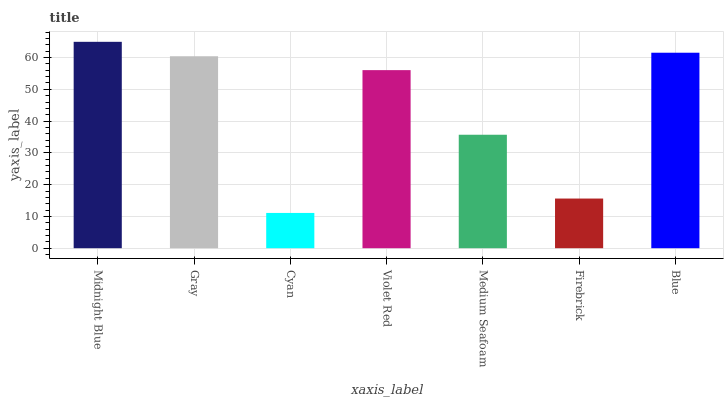Is Cyan the minimum?
Answer yes or no. Yes. Is Midnight Blue the maximum?
Answer yes or no. Yes. Is Gray the minimum?
Answer yes or no. No. Is Gray the maximum?
Answer yes or no. No. Is Midnight Blue greater than Gray?
Answer yes or no. Yes. Is Gray less than Midnight Blue?
Answer yes or no. Yes. Is Gray greater than Midnight Blue?
Answer yes or no. No. Is Midnight Blue less than Gray?
Answer yes or no. No. Is Violet Red the high median?
Answer yes or no. Yes. Is Violet Red the low median?
Answer yes or no. Yes. Is Blue the high median?
Answer yes or no. No. Is Gray the low median?
Answer yes or no. No. 